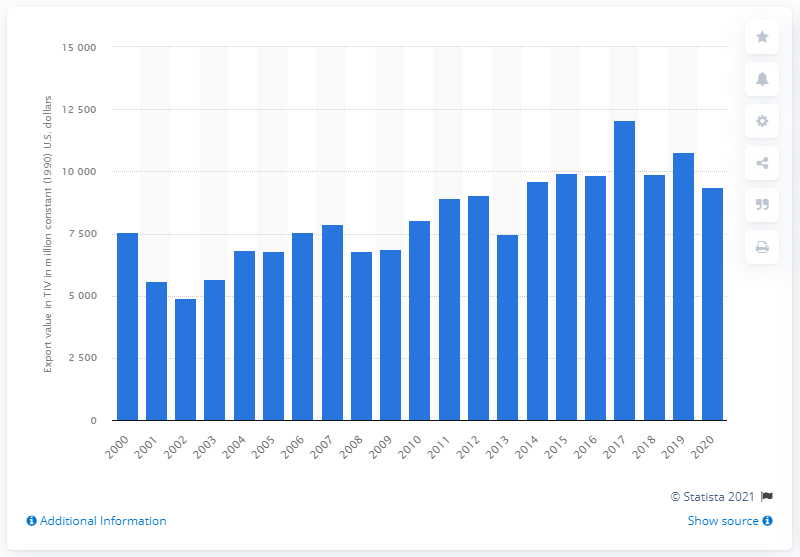Highlight a few significant elements in this photo. According to the latest data available, in 2020 the United States exported a total of 9,372 arms. 